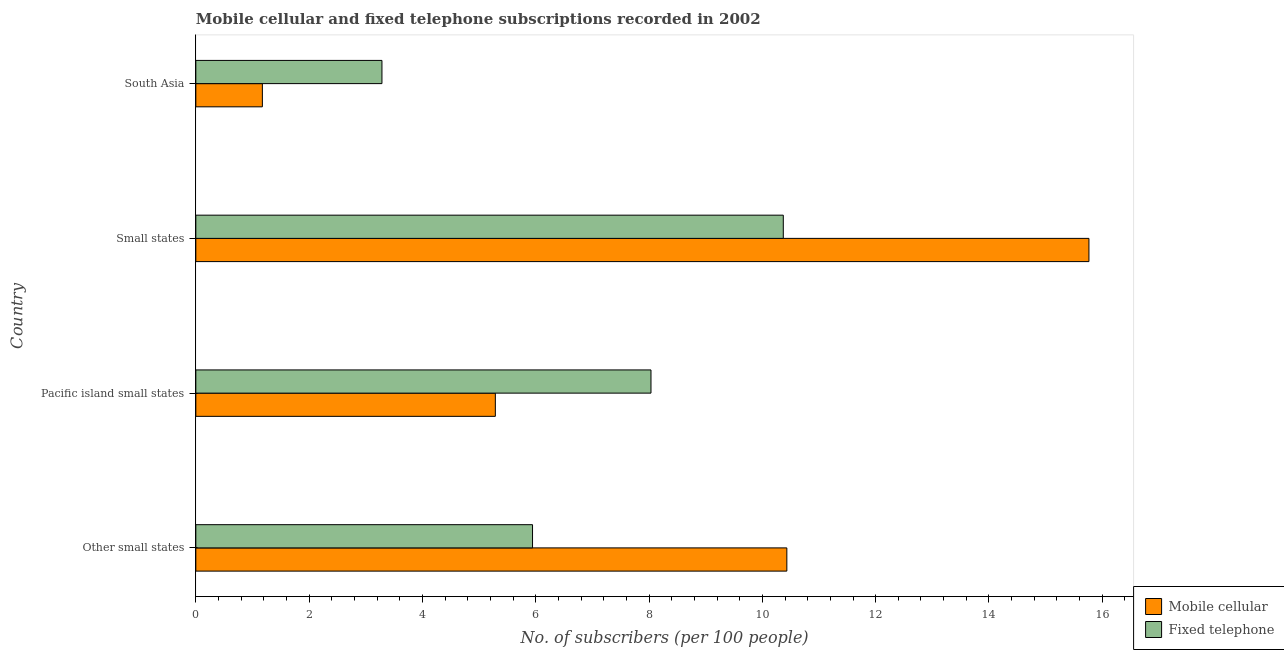How many different coloured bars are there?
Your answer should be compact. 2. How many groups of bars are there?
Your response must be concise. 4. What is the label of the 1st group of bars from the top?
Offer a very short reply. South Asia. What is the number of mobile cellular subscribers in Small states?
Your response must be concise. 15.76. Across all countries, what is the maximum number of fixed telephone subscribers?
Make the answer very short. 10.37. Across all countries, what is the minimum number of fixed telephone subscribers?
Provide a short and direct response. 3.29. In which country was the number of mobile cellular subscribers maximum?
Give a very brief answer. Small states. In which country was the number of mobile cellular subscribers minimum?
Provide a short and direct response. South Asia. What is the total number of mobile cellular subscribers in the graph?
Provide a short and direct response. 32.66. What is the difference between the number of mobile cellular subscribers in Other small states and that in Small states?
Your response must be concise. -5.33. What is the difference between the number of mobile cellular subscribers in Pacific island small states and the number of fixed telephone subscribers in Small states?
Provide a succinct answer. -5.08. What is the average number of fixed telephone subscribers per country?
Offer a terse response. 6.91. What is the difference between the number of mobile cellular subscribers and number of fixed telephone subscribers in Small states?
Make the answer very short. 5.39. In how many countries, is the number of fixed telephone subscribers greater than 4.8 ?
Offer a very short reply. 3. What is the ratio of the number of mobile cellular subscribers in Pacific island small states to that in South Asia?
Ensure brevity in your answer.  4.5. What is the difference between the highest and the second highest number of mobile cellular subscribers?
Make the answer very short. 5.33. What is the difference between the highest and the lowest number of mobile cellular subscribers?
Keep it short and to the point. 14.59. What does the 2nd bar from the top in Pacific island small states represents?
Offer a very short reply. Mobile cellular. What does the 2nd bar from the bottom in Small states represents?
Ensure brevity in your answer.  Fixed telephone. How many bars are there?
Offer a very short reply. 8. Are all the bars in the graph horizontal?
Offer a very short reply. Yes. Are the values on the major ticks of X-axis written in scientific E-notation?
Offer a terse response. No. Does the graph contain any zero values?
Your response must be concise. No. Does the graph contain grids?
Keep it short and to the point. No. Where does the legend appear in the graph?
Provide a short and direct response. Bottom right. How are the legend labels stacked?
Ensure brevity in your answer.  Vertical. What is the title of the graph?
Offer a terse response. Mobile cellular and fixed telephone subscriptions recorded in 2002. What is the label or title of the X-axis?
Keep it short and to the point. No. of subscribers (per 100 people). What is the label or title of the Y-axis?
Your answer should be very brief. Country. What is the No. of subscribers (per 100 people) in Mobile cellular in Other small states?
Your answer should be compact. 10.43. What is the No. of subscribers (per 100 people) of Fixed telephone in Other small states?
Give a very brief answer. 5.94. What is the No. of subscribers (per 100 people) in Mobile cellular in Pacific island small states?
Your response must be concise. 5.29. What is the No. of subscribers (per 100 people) in Fixed telephone in Pacific island small states?
Keep it short and to the point. 8.03. What is the No. of subscribers (per 100 people) in Mobile cellular in Small states?
Your answer should be very brief. 15.76. What is the No. of subscribers (per 100 people) in Fixed telephone in Small states?
Ensure brevity in your answer.  10.37. What is the No. of subscribers (per 100 people) of Mobile cellular in South Asia?
Your response must be concise. 1.17. What is the No. of subscribers (per 100 people) of Fixed telephone in South Asia?
Your answer should be compact. 3.29. Across all countries, what is the maximum No. of subscribers (per 100 people) in Mobile cellular?
Offer a terse response. 15.76. Across all countries, what is the maximum No. of subscribers (per 100 people) in Fixed telephone?
Make the answer very short. 10.37. Across all countries, what is the minimum No. of subscribers (per 100 people) of Mobile cellular?
Make the answer very short. 1.17. Across all countries, what is the minimum No. of subscribers (per 100 people) in Fixed telephone?
Your answer should be very brief. 3.29. What is the total No. of subscribers (per 100 people) of Mobile cellular in the graph?
Keep it short and to the point. 32.66. What is the total No. of subscribers (per 100 people) in Fixed telephone in the graph?
Provide a short and direct response. 27.63. What is the difference between the No. of subscribers (per 100 people) of Mobile cellular in Other small states and that in Pacific island small states?
Ensure brevity in your answer.  5.15. What is the difference between the No. of subscribers (per 100 people) of Fixed telephone in Other small states and that in Pacific island small states?
Your response must be concise. -2.09. What is the difference between the No. of subscribers (per 100 people) in Mobile cellular in Other small states and that in Small states?
Your answer should be compact. -5.33. What is the difference between the No. of subscribers (per 100 people) of Fixed telephone in Other small states and that in Small states?
Your response must be concise. -4.43. What is the difference between the No. of subscribers (per 100 people) of Mobile cellular in Other small states and that in South Asia?
Give a very brief answer. 9.26. What is the difference between the No. of subscribers (per 100 people) of Fixed telephone in Other small states and that in South Asia?
Give a very brief answer. 2.66. What is the difference between the No. of subscribers (per 100 people) of Mobile cellular in Pacific island small states and that in Small states?
Keep it short and to the point. -10.48. What is the difference between the No. of subscribers (per 100 people) in Fixed telephone in Pacific island small states and that in Small states?
Keep it short and to the point. -2.34. What is the difference between the No. of subscribers (per 100 people) in Mobile cellular in Pacific island small states and that in South Asia?
Your response must be concise. 4.11. What is the difference between the No. of subscribers (per 100 people) in Fixed telephone in Pacific island small states and that in South Asia?
Provide a succinct answer. 4.75. What is the difference between the No. of subscribers (per 100 people) of Mobile cellular in Small states and that in South Asia?
Provide a short and direct response. 14.59. What is the difference between the No. of subscribers (per 100 people) in Fixed telephone in Small states and that in South Asia?
Offer a very short reply. 7.08. What is the difference between the No. of subscribers (per 100 people) of Mobile cellular in Other small states and the No. of subscribers (per 100 people) of Fixed telephone in Pacific island small states?
Provide a short and direct response. 2.4. What is the difference between the No. of subscribers (per 100 people) in Mobile cellular in Other small states and the No. of subscribers (per 100 people) in Fixed telephone in Small states?
Your response must be concise. 0.06. What is the difference between the No. of subscribers (per 100 people) of Mobile cellular in Other small states and the No. of subscribers (per 100 people) of Fixed telephone in South Asia?
Keep it short and to the point. 7.15. What is the difference between the No. of subscribers (per 100 people) of Mobile cellular in Pacific island small states and the No. of subscribers (per 100 people) of Fixed telephone in Small states?
Keep it short and to the point. -5.08. What is the difference between the No. of subscribers (per 100 people) of Mobile cellular in Pacific island small states and the No. of subscribers (per 100 people) of Fixed telephone in South Asia?
Offer a very short reply. 2. What is the difference between the No. of subscribers (per 100 people) of Mobile cellular in Small states and the No. of subscribers (per 100 people) of Fixed telephone in South Asia?
Offer a very short reply. 12.48. What is the average No. of subscribers (per 100 people) of Mobile cellular per country?
Give a very brief answer. 8.16. What is the average No. of subscribers (per 100 people) in Fixed telephone per country?
Your answer should be very brief. 6.91. What is the difference between the No. of subscribers (per 100 people) of Mobile cellular and No. of subscribers (per 100 people) of Fixed telephone in Other small states?
Provide a succinct answer. 4.49. What is the difference between the No. of subscribers (per 100 people) in Mobile cellular and No. of subscribers (per 100 people) in Fixed telephone in Pacific island small states?
Your answer should be compact. -2.75. What is the difference between the No. of subscribers (per 100 people) in Mobile cellular and No. of subscribers (per 100 people) in Fixed telephone in Small states?
Keep it short and to the point. 5.39. What is the difference between the No. of subscribers (per 100 people) in Mobile cellular and No. of subscribers (per 100 people) in Fixed telephone in South Asia?
Your answer should be compact. -2.11. What is the ratio of the No. of subscribers (per 100 people) of Mobile cellular in Other small states to that in Pacific island small states?
Make the answer very short. 1.97. What is the ratio of the No. of subscribers (per 100 people) of Fixed telephone in Other small states to that in Pacific island small states?
Provide a short and direct response. 0.74. What is the ratio of the No. of subscribers (per 100 people) in Mobile cellular in Other small states to that in Small states?
Keep it short and to the point. 0.66. What is the ratio of the No. of subscribers (per 100 people) of Fixed telephone in Other small states to that in Small states?
Ensure brevity in your answer.  0.57. What is the ratio of the No. of subscribers (per 100 people) of Mobile cellular in Other small states to that in South Asia?
Provide a short and direct response. 8.88. What is the ratio of the No. of subscribers (per 100 people) in Fixed telephone in Other small states to that in South Asia?
Ensure brevity in your answer.  1.81. What is the ratio of the No. of subscribers (per 100 people) of Mobile cellular in Pacific island small states to that in Small states?
Keep it short and to the point. 0.34. What is the ratio of the No. of subscribers (per 100 people) of Fixed telephone in Pacific island small states to that in Small states?
Provide a short and direct response. 0.77. What is the ratio of the No. of subscribers (per 100 people) in Mobile cellular in Pacific island small states to that in South Asia?
Offer a terse response. 4.5. What is the ratio of the No. of subscribers (per 100 people) in Fixed telephone in Pacific island small states to that in South Asia?
Give a very brief answer. 2.45. What is the ratio of the No. of subscribers (per 100 people) in Mobile cellular in Small states to that in South Asia?
Offer a very short reply. 13.42. What is the ratio of the No. of subscribers (per 100 people) in Fixed telephone in Small states to that in South Asia?
Provide a succinct answer. 3.16. What is the difference between the highest and the second highest No. of subscribers (per 100 people) of Mobile cellular?
Your response must be concise. 5.33. What is the difference between the highest and the second highest No. of subscribers (per 100 people) in Fixed telephone?
Your answer should be very brief. 2.34. What is the difference between the highest and the lowest No. of subscribers (per 100 people) in Mobile cellular?
Offer a very short reply. 14.59. What is the difference between the highest and the lowest No. of subscribers (per 100 people) in Fixed telephone?
Offer a terse response. 7.08. 